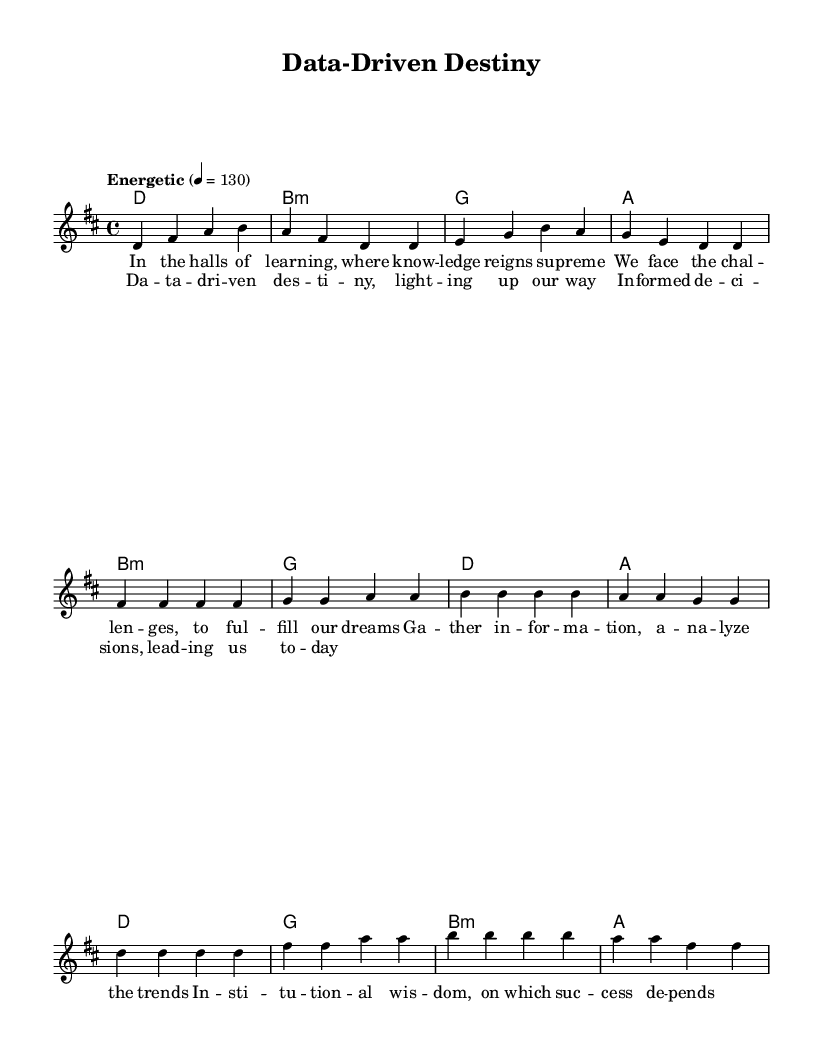What is the key signature of this music? The key signature indicates D major, which has two sharps: F# and C#. This can be seen at the beginning of the music sheet where the sharp symbols are displayed.
Answer: D major What is the time signature of this music? The time signature is shown at the beginning of the score as 4/4, which means there are four beats in each measure and the quarter note gets one beat.
Answer: 4/4 What tempo marking is indicated for this piece? The tempo marking is "Energetic" with a metronome marking of 130 beats per minute. This is noted at the beginning of the score which provides guidance on the speed of the music.
Answer: Energetic, 130 How many measures are in the chorus section? The chorus section is composed of four measures in total, which can be counted by looking at how many distinct sets of musical notes are grouped together in that part of the music.
Answer: 4 What is the first lyric of the verse? The first lyric recorded is "In the halls of learning," which can be found towards the beginning of the lyric portion associated with the melody.
Answer: In the halls of learning What is the interval of the first two notes in the melody? The first two notes in the melody are D and F#, which form a major third interval. This can be determined by counting the pitches between the notes while considering their positions on the staff.
Answer: Major third How does the harmony for the verse begin? The harmony for the verse begins with a D major chord, which is denoted by the "d" notation in the chord mode section of the score, indicating what chords should be played alongside the melody.
Answer: D major 